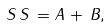<formula> <loc_0><loc_0><loc_500><loc_500>S \, S \, = A \, + \, B ,</formula> 